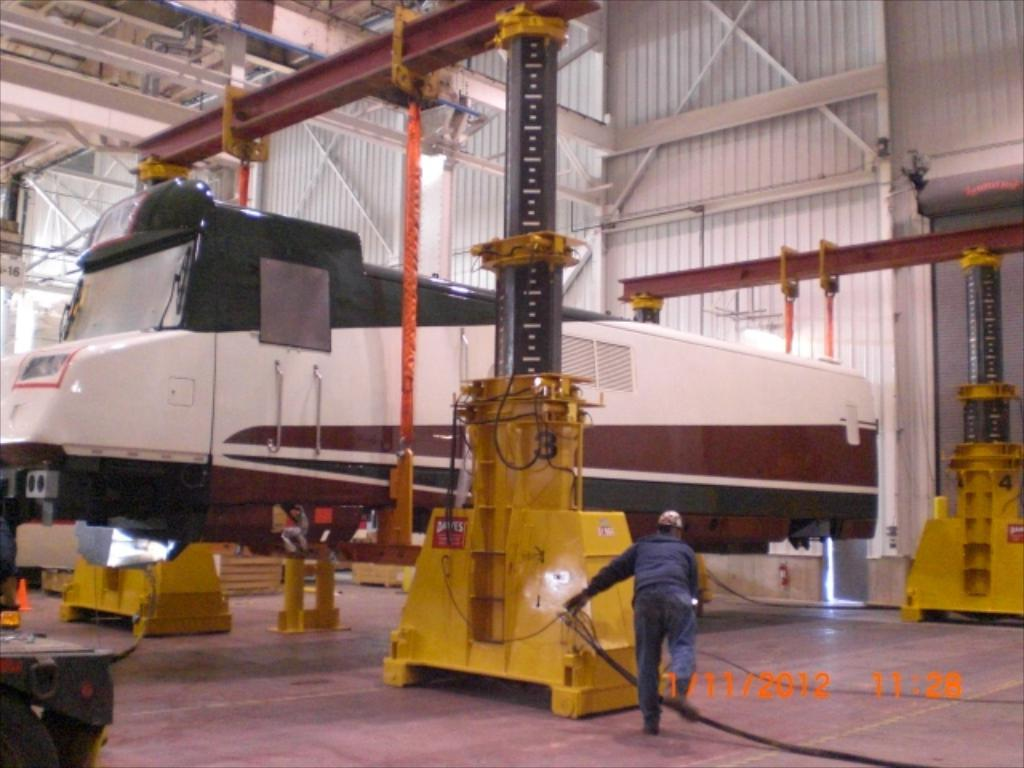What is the man in the image doing? The man is working in the image. Where is the man working? The man is in a factory setting. What can be seen in the background of the image? There are big rods and a train engine in the image. What type of material is present in the image? There are iron sheets in the image. What grade does the man receive for his work in the image? There is no indication of a grade or evaluation in the image; it simply shows the man working in a factory setting. 